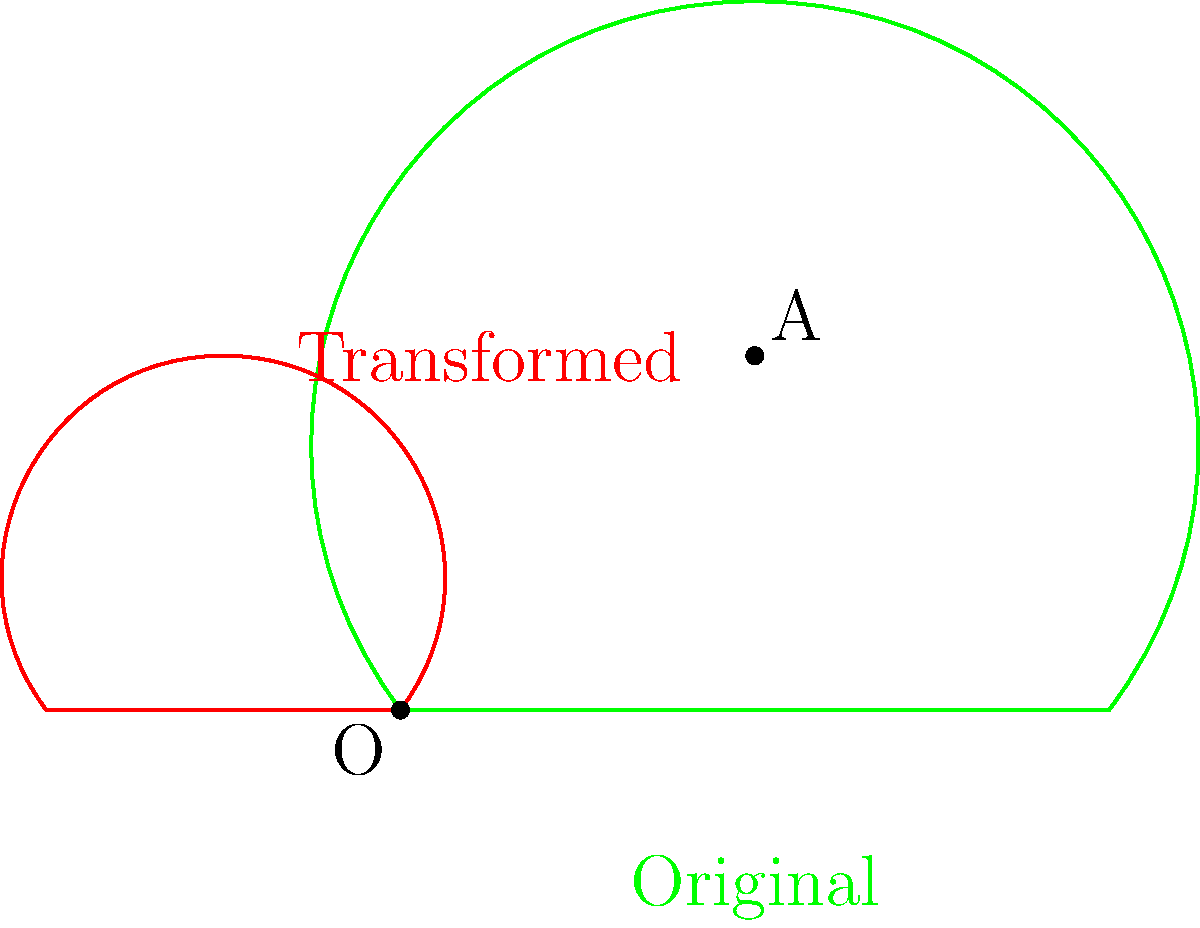A medicinal leaf shape undergoes a series of transformations in the following order: reflection across the line $y=x$, scaling by a factor of 0.5, and rotation by 90° clockwise around the origin. What is the final position of the point (2,0) on the original leaf after these transformations? Let's follow the transformations step-by-step:

1) Reflection across $y=x$:
   The point (2,0) becomes (0,2) after reflection.

2) Scaling by a factor of 0.5:
   (0,2) becomes (0,1) after scaling.

3) Rotation by 90° clockwise around the origin:
   To rotate (0,1) by 90° clockwise, we use the rotation matrix:
   $$\begin{pmatrix} \cos(-90°) & -\sin(-90°) \\ \sin(-90°) & \cos(-90°) \end{pmatrix} = \begin{pmatrix} 0 & 1 \\ -1 & 0 \end{pmatrix}$$

   Applying this to (0,1):
   $$\begin{pmatrix} 0 & 1 \\ -1 & 0 \end{pmatrix} \begin{pmatrix} 0 \\ 1 \end{pmatrix} = \begin{pmatrix} 1 \\ 0 \end{pmatrix}$$

Therefore, the final position of the point (2,0) after all transformations is (1,0).
Answer: (1,0) 